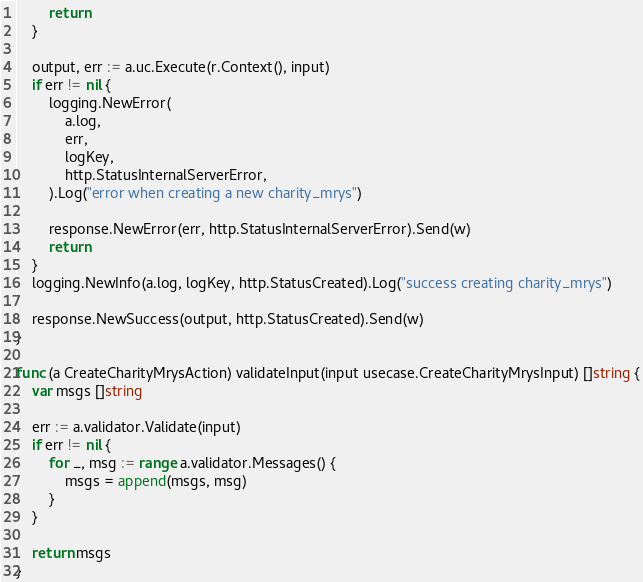Convert code to text. <code><loc_0><loc_0><loc_500><loc_500><_Go_>		return
	}

	output, err := a.uc.Execute(r.Context(), input)
	if err != nil {
		logging.NewError(
			a.log,
			err,
			logKey,
			http.StatusInternalServerError,
		).Log("error when creating a new charity_mrys")

		response.NewError(err, http.StatusInternalServerError).Send(w)
		return
	}
	logging.NewInfo(a.log, logKey, http.StatusCreated).Log("success creating charity_mrys")

	response.NewSuccess(output, http.StatusCreated).Send(w)
}

func (a CreateCharityMrysAction) validateInput(input usecase.CreateCharityMrysInput) []string {
	var msgs []string

	err := a.validator.Validate(input)
	if err != nil {
		for _, msg := range a.validator.Messages() {
			msgs = append(msgs, msg)
		}
	}

	return msgs
}
</code> 